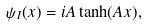<formula> <loc_0><loc_0><loc_500><loc_500>\psi _ { I } ( x ) = i A \tanh ( A x ) ,</formula> 